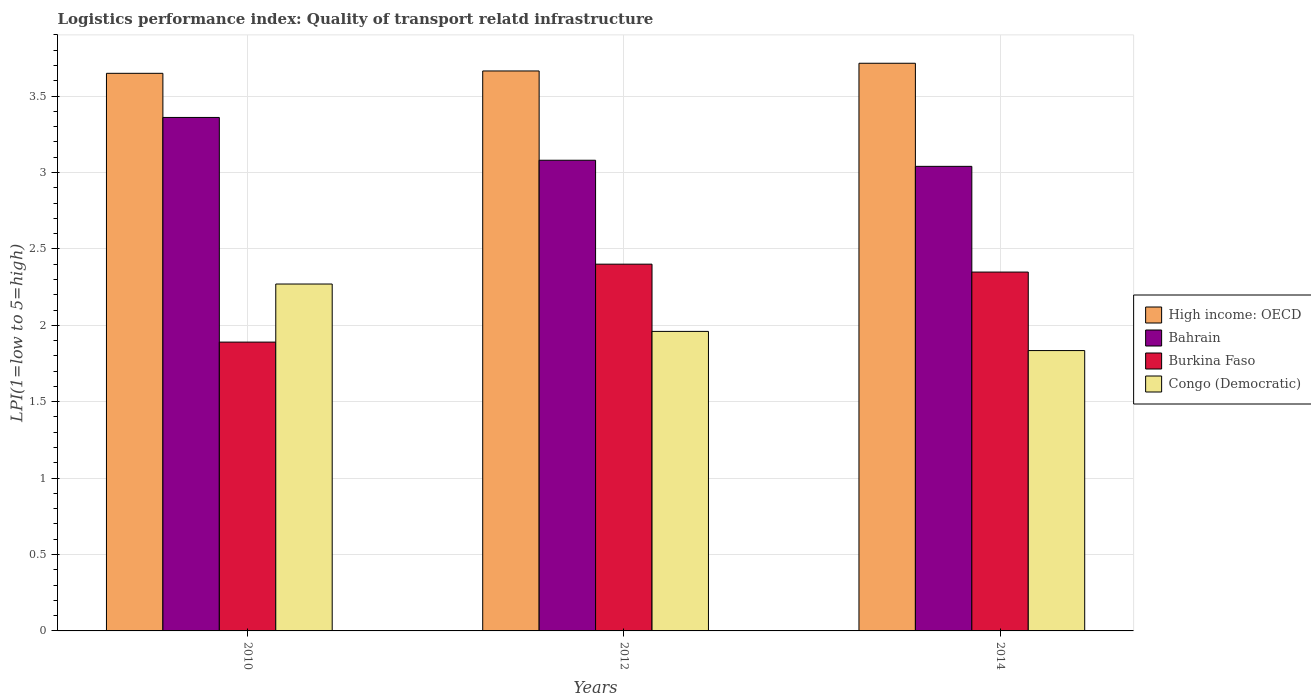How many different coloured bars are there?
Make the answer very short. 4. Are the number of bars per tick equal to the number of legend labels?
Provide a short and direct response. Yes. What is the logistics performance index in High income: OECD in 2010?
Keep it short and to the point. 3.65. Across all years, what is the maximum logistics performance index in Bahrain?
Ensure brevity in your answer.  3.36. Across all years, what is the minimum logistics performance index in High income: OECD?
Your answer should be very brief. 3.65. In which year was the logistics performance index in Congo (Democratic) minimum?
Provide a succinct answer. 2014. What is the total logistics performance index in Congo (Democratic) in the graph?
Your answer should be compact. 6.06. What is the difference between the logistics performance index in High income: OECD in 2012 and that in 2014?
Your answer should be very brief. -0.05. What is the difference between the logistics performance index in Burkina Faso in 2014 and the logistics performance index in Congo (Democratic) in 2012?
Keep it short and to the point. 0.39. What is the average logistics performance index in Bahrain per year?
Provide a short and direct response. 3.16. In the year 2012, what is the difference between the logistics performance index in High income: OECD and logistics performance index in Burkina Faso?
Provide a succinct answer. 1.26. What is the ratio of the logistics performance index in Bahrain in 2010 to that in 2012?
Ensure brevity in your answer.  1.09. Is the difference between the logistics performance index in High income: OECD in 2010 and 2012 greater than the difference between the logistics performance index in Burkina Faso in 2010 and 2012?
Your answer should be very brief. Yes. What is the difference between the highest and the second highest logistics performance index in High income: OECD?
Keep it short and to the point. 0.05. What is the difference between the highest and the lowest logistics performance index in High income: OECD?
Make the answer very short. 0.07. In how many years, is the logistics performance index in Burkina Faso greater than the average logistics performance index in Burkina Faso taken over all years?
Your response must be concise. 2. Is it the case that in every year, the sum of the logistics performance index in Burkina Faso and logistics performance index in Congo (Democratic) is greater than the sum of logistics performance index in Bahrain and logistics performance index in High income: OECD?
Provide a succinct answer. No. What does the 4th bar from the left in 2012 represents?
Offer a terse response. Congo (Democratic). What does the 1st bar from the right in 2014 represents?
Give a very brief answer. Congo (Democratic). Are all the bars in the graph horizontal?
Your answer should be very brief. No. What is the difference between two consecutive major ticks on the Y-axis?
Make the answer very short. 0.5. Are the values on the major ticks of Y-axis written in scientific E-notation?
Offer a terse response. No. Does the graph contain grids?
Provide a succinct answer. Yes. What is the title of the graph?
Offer a terse response. Logistics performance index: Quality of transport relatd infrastructure. Does "Sri Lanka" appear as one of the legend labels in the graph?
Your answer should be very brief. No. What is the label or title of the Y-axis?
Offer a very short reply. LPI(1=low to 5=high). What is the LPI(1=low to 5=high) of High income: OECD in 2010?
Keep it short and to the point. 3.65. What is the LPI(1=low to 5=high) of Bahrain in 2010?
Give a very brief answer. 3.36. What is the LPI(1=low to 5=high) of Burkina Faso in 2010?
Give a very brief answer. 1.89. What is the LPI(1=low to 5=high) in Congo (Democratic) in 2010?
Offer a very short reply. 2.27. What is the LPI(1=low to 5=high) in High income: OECD in 2012?
Offer a very short reply. 3.66. What is the LPI(1=low to 5=high) in Bahrain in 2012?
Offer a terse response. 3.08. What is the LPI(1=low to 5=high) in Congo (Democratic) in 2012?
Offer a very short reply. 1.96. What is the LPI(1=low to 5=high) in High income: OECD in 2014?
Offer a very short reply. 3.71. What is the LPI(1=low to 5=high) in Bahrain in 2014?
Ensure brevity in your answer.  3.04. What is the LPI(1=low to 5=high) in Burkina Faso in 2014?
Provide a succinct answer. 2.35. What is the LPI(1=low to 5=high) of Congo (Democratic) in 2014?
Your response must be concise. 1.83. Across all years, what is the maximum LPI(1=low to 5=high) of High income: OECD?
Your answer should be compact. 3.71. Across all years, what is the maximum LPI(1=low to 5=high) in Bahrain?
Offer a very short reply. 3.36. Across all years, what is the maximum LPI(1=low to 5=high) of Congo (Democratic)?
Your answer should be very brief. 2.27. Across all years, what is the minimum LPI(1=low to 5=high) of High income: OECD?
Your answer should be very brief. 3.65. Across all years, what is the minimum LPI(1=low to 5=high) of Bahrain?
Your answer should be compact. 3.04. Across all years, what is the minimum LPI(1=low to 5=high) of Burkina Faso?
Keep it short and to the point. 1.89. Across all years, what is the minimum LPI(1=low to 5=high) in Congo (Democratic)?
Offer a terse response. 1.83. What is the total LPI(1=low to 5=high) of High income: OECD in the graph?
Your response must be concise. 11.03. What is the total LPI(1=low to 5=high) in Bahrain in the graph?
Give a very brief answer. 9.48. What is the total LPI(1=low to 5=high) in Burkina Faso in the graph?
Ensure brevity in your answer.  6.64. What is the total LPI(1=low to 5=high) in Congo (Democratic) in the graph?
Your answer should be very brief. 6.06. What is the difference between the LPI(1=low to 5=high) in High income: OECD in 2010 and that in 2012?
Your answer should be very brief. -0.02. What is the difference between the LPI(1=low to 5=high) of Bahrain in 2010 and that in 2012?
Your response must be concise. 0.28. What is the difference between the LPI(1=low to 5=high) of Burkina Faso in 2010 and that in 2012?
Make the answer very short. -0.51. What is the difference between the LPI(1=low to 5=high) in Congo (Democratic) in 2010 and that in 2012?
Provide a short and direct response. 0.31. What is the difference between the LPI(1=low to 5=high) in High income: OECD in 2010 and that in 2014?
Offer a very short reply. -0.07. What is the difference between the LPI(1=low to 5=high) in Bahrain in 2010 and that in 2014?
Provide a succinct answer. 0.32. What is the difference between the LPI(1=low to 5=high) of Burkina Faso in 2010 and that in 2014?
Your answer should be very brief. -0.46. What is the difference between the LPI(1=low to 5=high) in Congo (Democratic) in 2010 and that in 2014?
Give a very brief answer. 0.44. What is the difference between the LPI(1=low to 5=high) in High income: OECD in 2012 and that in 2014?
Keep it short and to the point. -0.05. What is the difference between the LPI(1=low to 5=high) in Burkina Faso in 2012 and that in 2014?
Your answer should be compact. 0.05. What is the difference between the LPI(1=low to 5=high) of Congo (Democratic) in 2012 and that in 2014?
Make the answer very short. 0.13. What is the difference between the LPI(1=low to 5=high) of High income: OECD in 2010 and the LPI(1=low to 5=high) of Bahrain in 2012?
Offer a very short reply. 0.57. What is the difference between the LPI(1=low to 5=high) in High income: OECD in 2010 and the LPI(1=low to 5=high) in Burkina Faso in 2012?
Your answer should be very brief. 1.25. What is the difference between the LPI(1=low to 5=high) in High income: OECD in 2010 and the LPI(1=low to 5=high) in Congo (Democratic) in 2012?
Your answer should be compact. 1.69. What is the difference between the LPI(1=low to 5=high) in Bahrain in 2010 and the LPI(1=low to 5=high) in Burkina Faso in 2012?
Ensure brevity in your answer.  0.96. What is the difference between the LPI(1=low to 5=high) of Bahrain in 2010 and the LPI(1=low to 5=high) of Congo (Democratic) in 2012?
Your answer should be very brief. 1.4. What is the difference between the LPI(1=low to 5=high) of Burkina Faso in 2010 and the LPI(1=low to 5=high) of Congo (Democratic) in 2012?
Offer a very short reply. -0.07. What is the difference between the LPI(1=low to 5=high) in High income: OECD in 2010 and the LPI(1=low to 5=high) in Bahrain in 2014?
Your answer should be very brief. 0.61. What is the difference between the LPI(1=low to 5=high) of High income: OECD in 2010 and the LPI(1=low to 5=high) of Burkina Faso in 2014?
Give a very brief answer. 1.3. What is the difference between the LPI(1=low to 5=high) in High income: OECD in 2010 and the LPI(1=low to 5=high) in Congo (Democratic) in 2014?
Keep it short and to the point. 1.81. What is the difference between the LPI(1=low to 5=high) of Bahrain in 2010 and the LPI(1=low to 5=high) of Burkina Faso in 2014?
Provide a short and direct response. 1.01. What is the difference between the LPI(1=low to 5=high) in Bahrain in 2010 and the LPI(1=low to 5=high) in Congo (Democratic) in 2014?
Provide a succinct answer. 1.53. What is the difference between the LPI(1=low to 5=high) in Burkina Faso in 2010 and the LPI(1=low to 5=high) in Congo (Democratic) in 2014?
Make the answer very short. 0.06. What is the difference between the LPI(1=low to 5=high) of High income: OECD in 2012 and the LPI(1=low to 5=high) of Bahrain in 2014?
Your answer should be very brief. 0.62. What is the difference between the LPI(1=low to 5=high) in High income: OECD in 2012 and the LPI(1=low to 5=high) in Burkina Faso in 2014?
Make the answer very short. 1.32. What is the difference between the LPI(1=low to 5=high) in High income: OECD in 2012 and the LPI(1=low to 5=high) in Congo (Democratic) in 2014?
Provide a succinct answer. 1.83. What is the difference between the LPI(1=low to 5=high) in Bahrain in 2012 and the LPI(1=low to 5=high) in Burkina Faso in 2014?
Give a very brief answer. 0.73. What is the difference between the LPI(1=low to 5=high) in Bahrain in 2012 and the LPI(1=low to 5=high) in Congo (Democratic) in 2014?
Ensure brevity in your answer.  1.25. What is the difference between the LPI(1=low to 5=high) in Burkina Faso in 2012 and the LPI(1=low to 5=high) in Congo (Democratic) in 2014?
Your response must be concise. 0.57. What is the average LPI(1=low to 5=high) in High income: OECD per year?
Offer a terse response. 3.68. What is the average LPI(1=low to 5=high) of Bahrain per year?
Keep it short and to the point. 3.16. What is the average LPI(1=low to 5=high) of Burkina Faso per year?
Your response must be concise. 2.21. What is the average LPI(1=low to 5=high) of Congo (Democratic) per year?
Your answer should be compact. 2.02. In the year 2010, what is the difference between the LPI(1=low to 5=high) in High income: OECD and LPI(1=low to 5=high) in Bahrain?
Make the answer very short. 0.29. In the year 2010, what is the difference between the LPI(1=low to 5=high) in High income: OECD and LPI(1=low to 5=high) in Burkina Faso?
Offer a very short reply. 1.76. In the year 2010, what is the difference between the LPI(1=low to 5=high) of High income: OECD and LPI(1=low to 5=high) of Congo (Democratic)?
Keep it short and to the point. 1.38. In the year 2010, what is the difference between the LPI(1=low to 5=high) in Bahrain and LPI(1=low to 5=high) in Burkina Faso?
Your answer should be compact. 1.47. In the year 2010, what is the difference between the LPI(1=low to 5=high) of Bahrain and LPI(1=low to 5=high) of Congo (Democratic)?
Make the answer very short. 1.09. In the year 2010, what is the difference between the LPI(1=low to 5=high) in Burkina Faso and LPI(1=low to 5=high) in Congo (Democratic)?
Make the answer very short. -0.38. In the year 2012, what is the difference between the LPI(1=low to 5=high) in High income: OECD and LPI(1=low to 5=high) in Bahrain?
Your answer should be compact. 0.58. In the year 2012, what is the difference between the LPI(1=low to 5=high) in High income: OECD and LPI(1=low to 5=high) in Burkina Faso?
Your answer should be very brief. 1.26. In the year 2012, what is the difference between the LPI(1=low to 5=high) of High income: OECD and LPI(1=low to 5=high) of Congo (Democratic)?
Ensure brevity in your answer.  1.7. In the year 2012, what is the difference between the LPI(1=low to 5=high) in Bahrain and LPI(1=low to 5=high) in Burkina Faso?
Ensure brevity in your answer.  0.68. In the year 2012, what is the difference between the LPI(1=low to 5=high) in Bahrain and LPI(1=low to 5=high) in Congo (Democratic)?
Your response must be concise. 1.12. In the year 2012, what is the difference between the LPI(1=low to 5=high) in Burkina Faso and LPI(1=low to 5=high) in Congo (Democratic)?
Your response must be concise. 0.44. In the year 2014, what is the difference between the LPI(1=low to 5=high) in High income: OECD and LPI(1=low to 5=high) in Bahrain?
Keep it short and to the point. 0.67. In the year 2014, what is the difference between the LPI(1=low to 5=high) of High income: OECD and LPI(1=low to 5=high) of Burkina Faso?
Keep it short and to the point. 1.37. In the year 2014, what is the difference between the LPI(1=low to 5=high) of High income: OECD and LPI(1=low to 5=high) of Congo (Democratic)?
Keep it short and to the point. 1.88. In the year 2014, what is the difference between the LPI(1=low to 5=high) of Bahrain and LPI(1=low to 5=high) of Burkina Faso?
Make the answer very short. 0.69. In the year 2014, what is the difference between the LPI(1=low to 5=high) in Bahrain and LPI(1=low to 5=high) in Congo (Democratic)?
Ensure brevity in your answer.  1.21. In the year 2014, what is the difference between the LPI(1=low to 5=high) in Burkina Faso and LPI(1=low to 5=high) in Congo (Democratic)?
Keep it short and to the point. 0.51. What is the ratio of the LPI(1=low to 5=high) of High income: OECD in 2010 to that in 2012?
Your answer should be compact. 1. What is the ratio of the LPI(1=low to 5=high) of Burkina Faso in 2010 to that in 2012?
Offer a very short reply. 0.79. What is the ratio of the LPI(1=low to 5=high) in Congo (Democratic) in 2010 to that in 2012?
Provide a short and direct response. 1.16. What is the ratio of the LPI(1=low to 5=high) in High income: OECD in 2010 to that in 2014?
Your answer should be compact. 0.98. What is the ratio of the LPI(1=low to 5=high) in Bahrain in 2010 to that in 2014?
Give a very brief answer. 1.11. What is the ratio of the LPI(1=low to 5=high) in Burkina Faso in 2010 to that in 2014?
Offer a terse response. 0.8. What is the ratio of the LPI(1=low to 5=high) in Congo (Democratic) in 2010 to that in 2014?
Make the answer very short. 1.24. What is the ratio of the LPI(1=low to 5=high) in High income: OECD in 2012 to that in 2014?
Make the answer very short. 0.99. What is the ratio of the LPI(1=low to 5=high) of Bahrain in 2012 to that in 2014?
Your response must be concise. 1.01. What is the ratio of the LPI(1=low to 5=high) of Burkina Faso in 2012 to that in 2014?
Your answer should be very brief. 1.02. What is the ratio of the LPI(1=low to 5=high) of Congo (Democratic) in 2012 to that in 2014?
Your answer should be very brief. 1.07. What is the difference between the highest and the second highest LPI(1=low to 5=high) of High income: OECD?
Provide a short and direct response. 0.05. What is the difference between the highest and the second highest LPI(1=low to 5=high) of Bahrain?
Provide a succinct answer. 0.28. What is the difference between the highest and the second highest LPI(1=low to 5=high) of Burkina Faso?
Give a very brief answer. 0.05. What is the difference between the highest and the second highest LPI(1=low to 5=high) in Congo (Democratic)?
Keep it short and to the point. 0.31. What is the difference between the highest and the lowest LPI(1=low to 5=high) of High income: OECD?
Offer a very short reply. 0.07. What is the difference between the highest and the lowest LPI(1=low to 5=high) in Bahrain?
Your answer should be very brief. 0.32. What is the difference between the highest and the lowest LPI(1=low to 5=high) in Burkina Faso?
Your response must be concise. 0.51. What is the difference between the highest and the lowest LPI(1=low to 5=high) in Congo (Democratic)?
Offer a terse response. 0.44. 